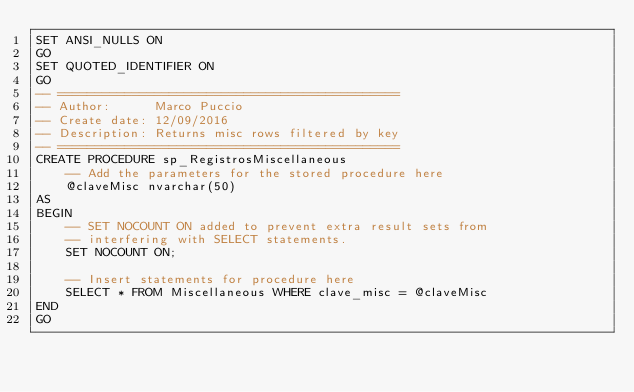Convert code to text. <code><loc_0><loc_0><loc_500><loc_500><_SQL_>SET ANSI_NULLS ON
GO
SET QUOTED_IDENTIFIER ON
GO
-- ==============================================
-- Author:		Marco Puccio
-- Create date: 12/09/2016
-- Description:	Returns misc rows filtered by key
-- ==============================================
CREATE PROCEDURE sp_RegistrosMiscellaneous 
	-- Add the parameters for the stored procedure here
	@claveMisc nvarchar(50)
AS
BEGIN
	-- SET NOCOUNT ON added to prevent extra result sets from
	-- interfering with SELECT statements.
	SET NOCOUNT ON;

    -- Insert statements for procedure here
	SELECT * FROM Miscellaneous WHERE clave_misc = @claveMisc
END
GO
</code> 